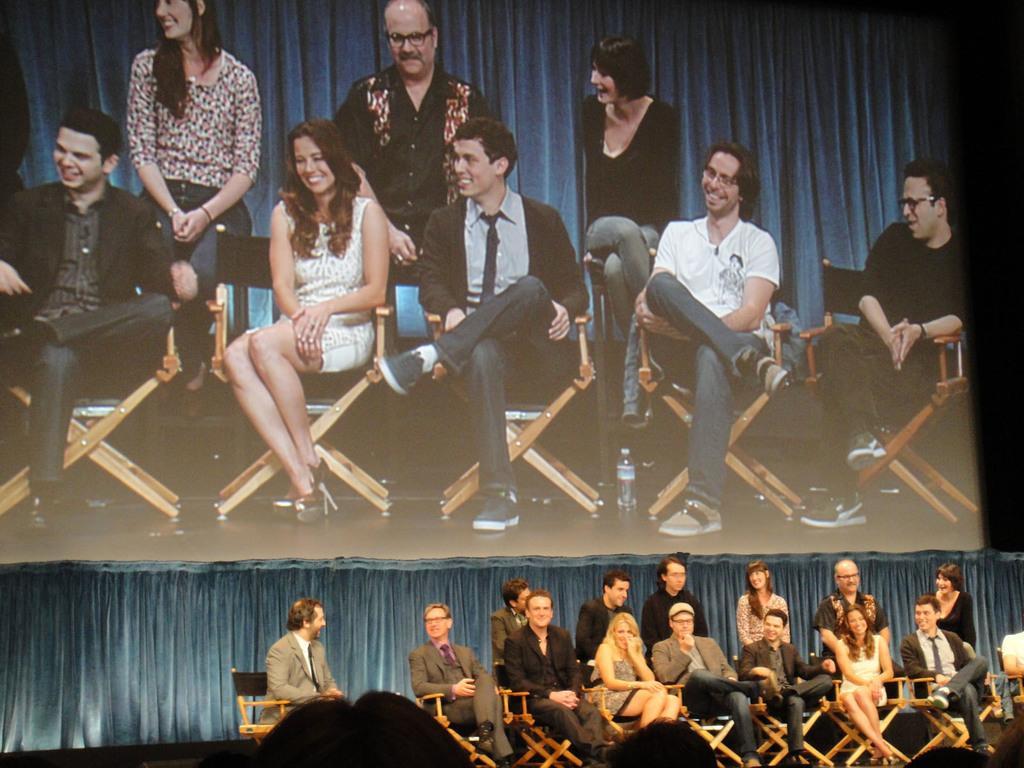Please provide a concise description of this image. In this picture we can see a group of people, some people are sitting on chairs, on the right side we can see an object and in the background we can see a curtain, screen. 